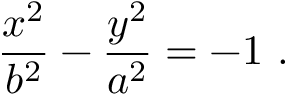Convert formula to latex. <formula><loc_0><loc_0><loc_500><loc_500>{ \frac { x ^ { 2 } } { b ^ { 2 } } } - { \frac { y ^ { 2 } } { a ^ { 2 } } } = - 1 \ .</formula> 